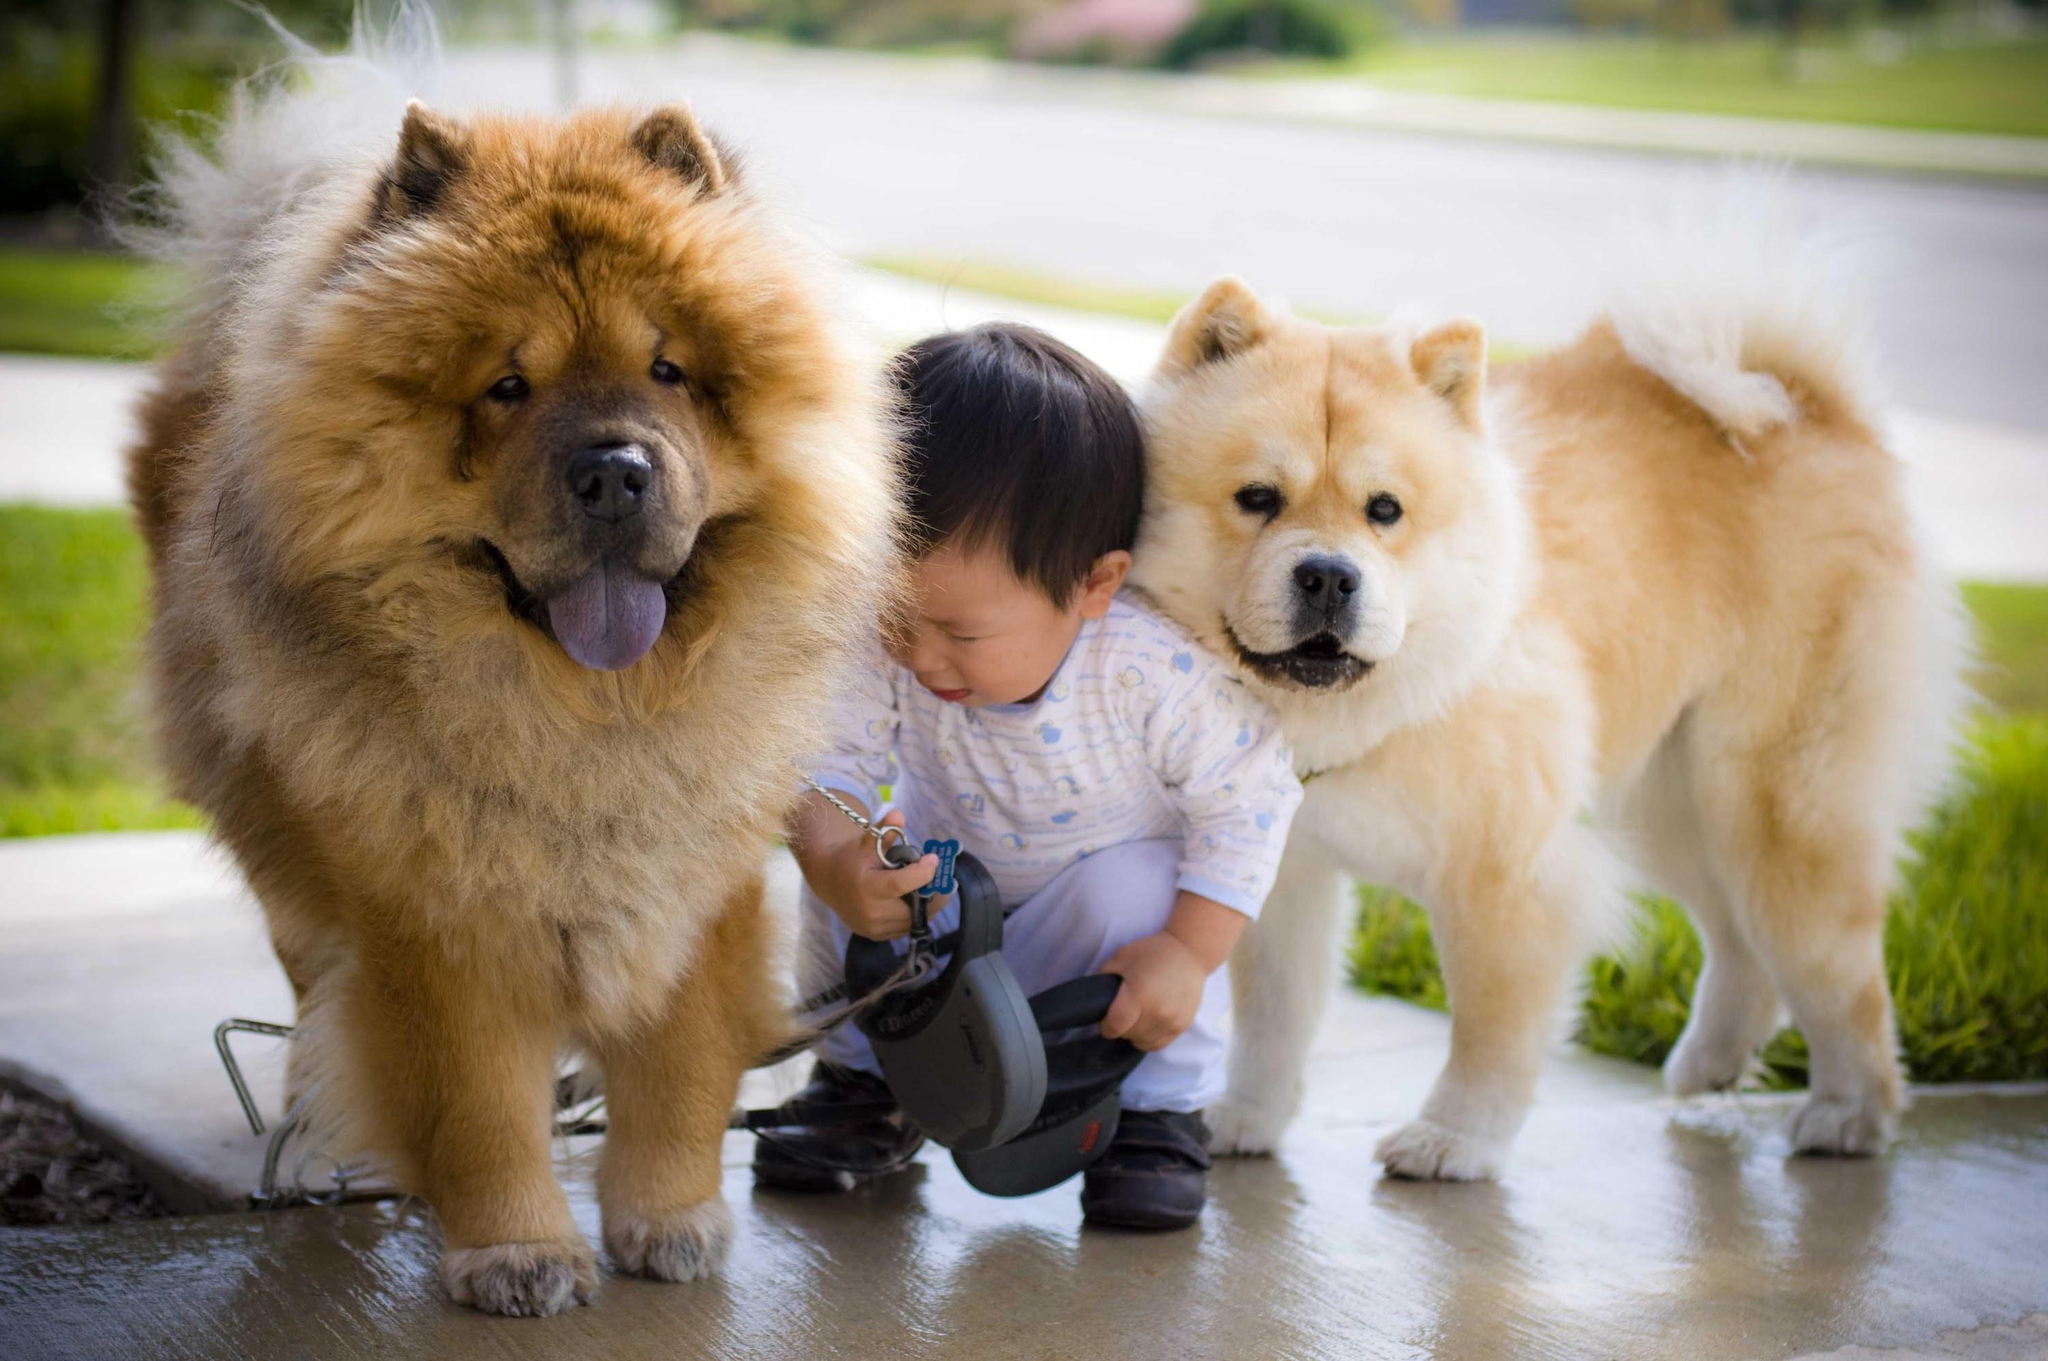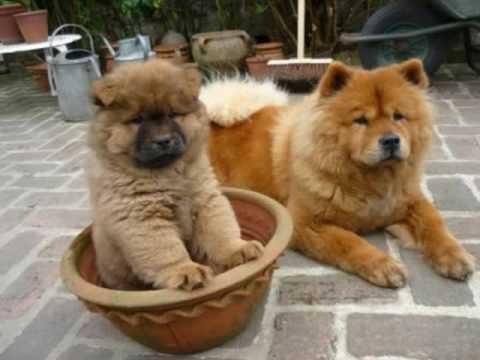The first image is the image on the left, the second image is the image on the right. For the images displayed, is the sentence "There are more than 4 dogs." factually correct? Answer yes or no. No. The first image is the image on the left, the second image is the image on the right. Evaluate the accuracy of this statement regarding the images: "There are no less than four dogs in one of the images.". Is it true? Answer yes or no. No. 